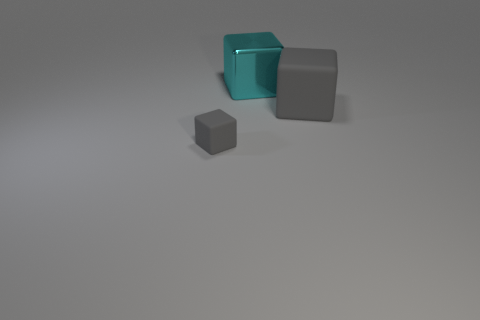Add 3 cyan things. How many objects exist? 6 Subtract 0 red cylinders. How many objects are left? 3 Subtract all cyan matte blocks. Subtract all cyan shiny cubes. How many objects are left? 2 Add 3 big metal blocks. How many big metal blocks are left? 4 Add 3 yellow matte cubes. How many yellow matte cubes exist? 3 